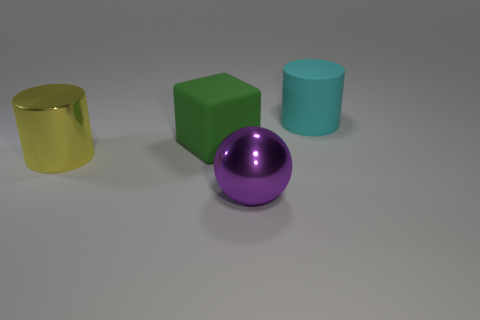What number of other large cylinders are the same material as the big cyan cylinder?
Offer a very short reply. 0. How many small gray metal things are there?
Keep it short and to the point. 0. There is a metallic thing that is in front of the yellow cylinder; is it the same color as the large cylinder that is to the right of the big yellow cylinder?
Make the answer very short. No. What number of large yellow cylinders are behind the yellow metallic thing?
Give a very brief answer. 0. Are there any big purple objects of the same shape as the cyan matte thing?
Provide a succinct answer. No. Is the large cylinder that is behind the yellow metal cylinder made of the same material as the cylinder that is to the left of the large metallic sphere?
Provide a short and direct response. No. There is a matte thing that is left of the shiny object that is right of the cylinder left of the big cyan matte cylinder; what size is it?
Ensure brevity in your answer.  Large. There is a cube that is the same size as the purple metal object; what material is it?
Make the answer very short. Rubber. Are there any other purple metal objects of the same size as the purple metallic object?
Provide a short and direct response. No. Do the big purple thing and the cyan rubber thing have the same shape?
Make the answer very short. No. 